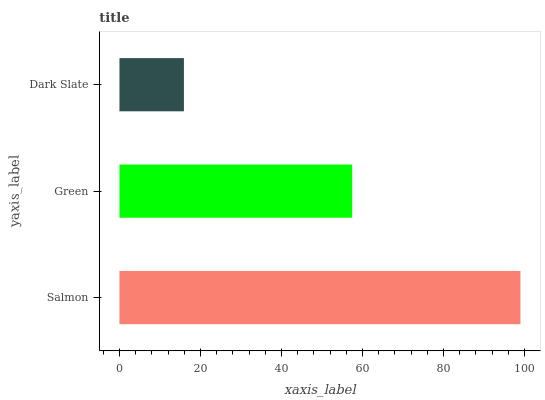Is Dark Slate the minimum?
Answer yes or no. Yes. Is Salmon the maximum?
Answer yes or no. Yes. Is Green the minimum?
Answer yes or no. No. Is Green the maximum?
Answer yes or no. No. Is Salmon greater than Green?
Answer yes or no. Yes. Is Green less than Salmon?
Answer yes or no. Yes. Is Green greater than Salmon?
Answer yes or no. No. Is Salmon less than Green?
Answer yes or no. No. Is Green the high median?
Answer yes or no. Yes. Is Green the low median?
Answer yes or no. Yes. Is Dark Slate the high median?
Answer yes or no. No. Is Dark Slate the low median?
Answer yes or no. No. 